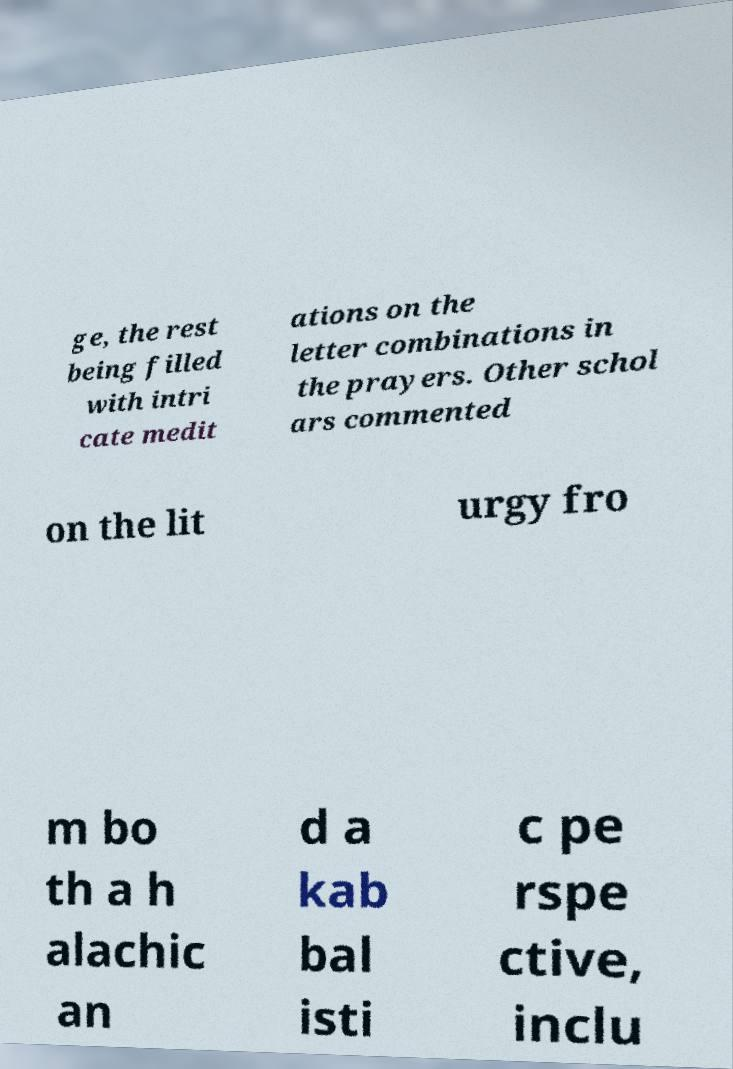I need the written content from this picture converted into text. Can you do that? ge, the rest being filled with intri cate medit ations on the letter combinations in the prayers. Other schol ars commented on the lit urgy fro m bo th a h alachic an d a kab bal isti c pe rspe ctive, inclu 